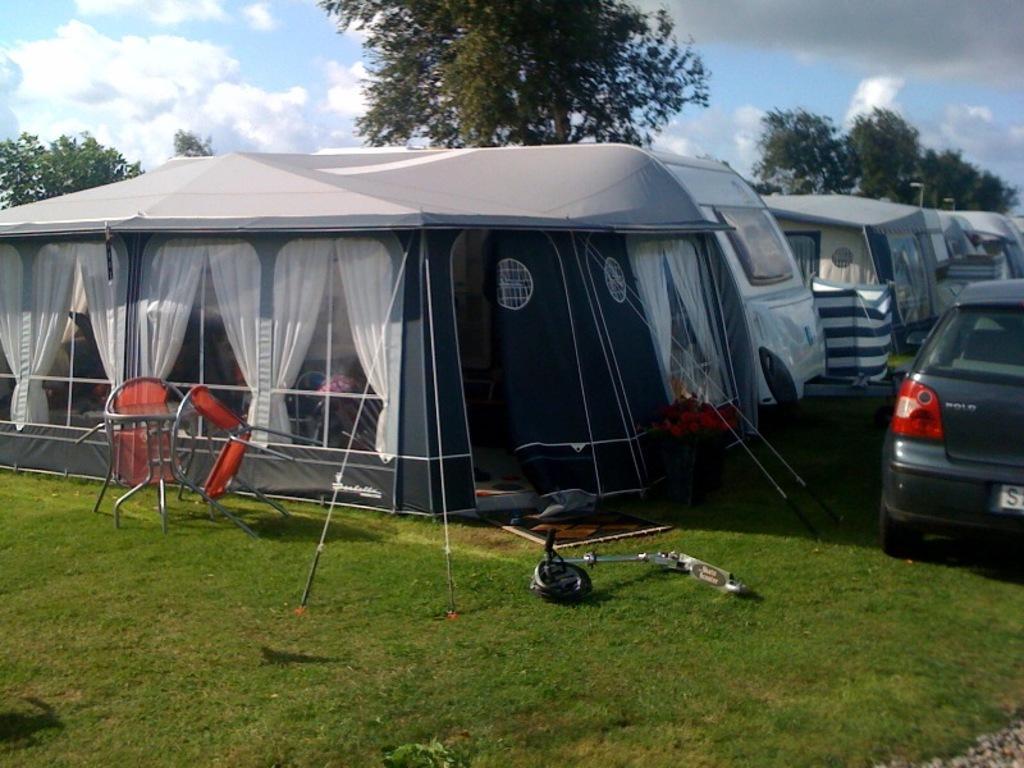Can you describe this image briefly? Here in this picture we can see tents and trucks and cars present all over there on the ground, which is covered with grass over there and we can see chairs and curtains also visible over there and behind that we can see trees present all over there and we can see clouds in the sky. 